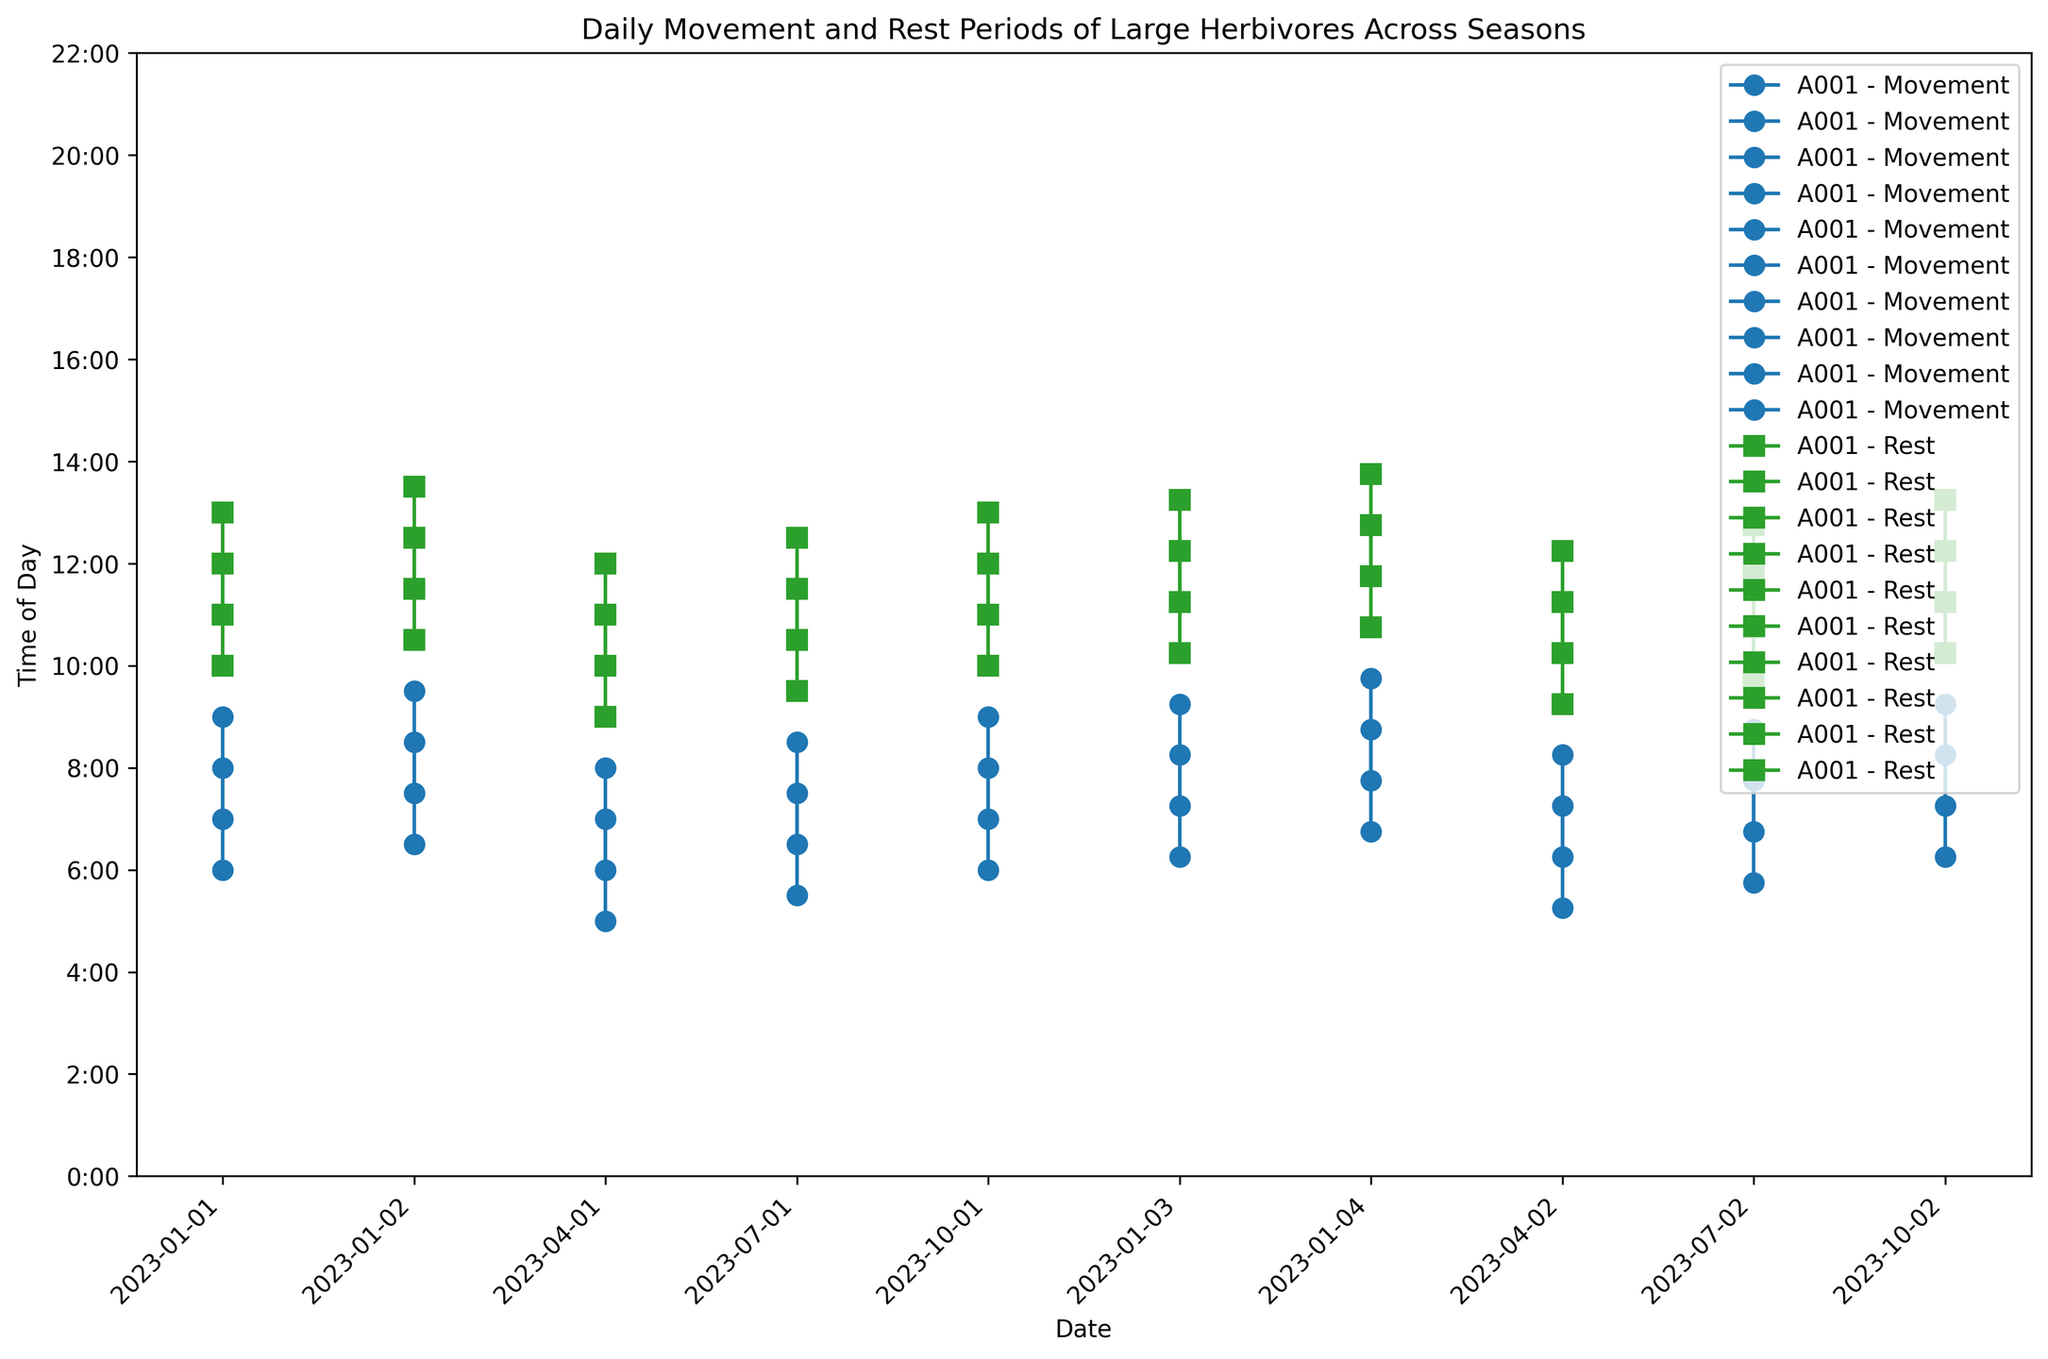What is the earliest movement start time recorded for Animal A001? To find the earliest recorded start time for Animal A001’s movements, we check all the movement events and identify the earliest time. The start times are 06:00, 06:30, 05:00, 05:30, 06:00, 06:15, 06:45, 05:15, 05:45, and 06:15. The earliest of these is 05:00.
Answer: 05:00 On average, is the daily movement start time for Animal A002 earlier or later than it is for Animal A001 in July? Calculate the average start time for movements in July for both animals.
For Animal A001: (05:30 + 05:45) / 2 = 05:37.5
For Animal A002: (06:30 + 06:45) / 2 = 06:37.5. 
Comparing the averages, the movement start time for A002 is one hour later.
Answer: Later Compare the total duration of movement periods for Animal A001 and Animal A002 on 2023-01-01. Which animal had a longer movement duration? For Animal A001 on 2023-01-01: Movement from 06:00 to 08:00 equals 2 hours. 
For Animal A002 on 2023-01-01: Movement from 07:00 to 09:00 equals 2 hours. 
Both animals have the same movement duration on this day.
Answer: Equal What is the typical (median) duration of rest periods for Animal A001 across all recorded dates? First, list all rest period durations for Animal A001: 2, 2, 2, 2, 2, 2, 2, 2, 2, 2. Since all rest periods are 2 hours, the median duration is also 2 hours.
Answer: 2 hours 